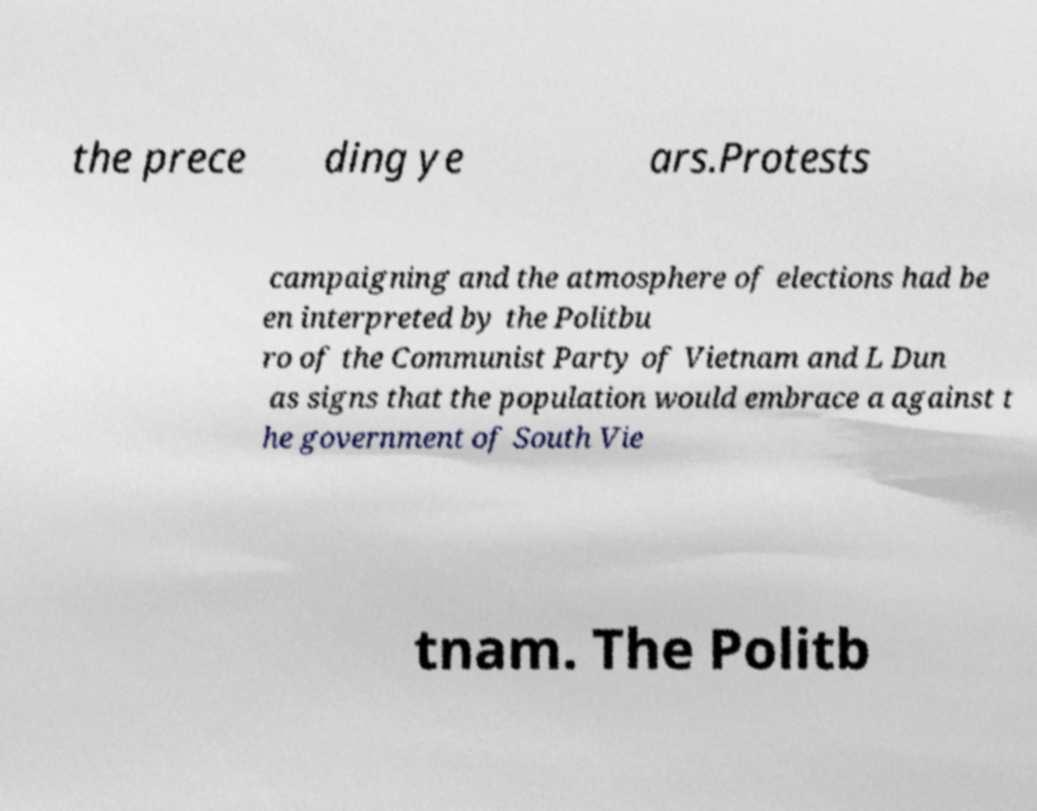I need the written content from this picture converted into text. Can you do that? the prece ding ye ars.Protests campaigning and the atmosphere of elections had be en interpreted by the Politbu ro of the Communist Party of Vietnam and L Dun as signs that the population would embrace a against t he government of South Vie tnam. The Politb 